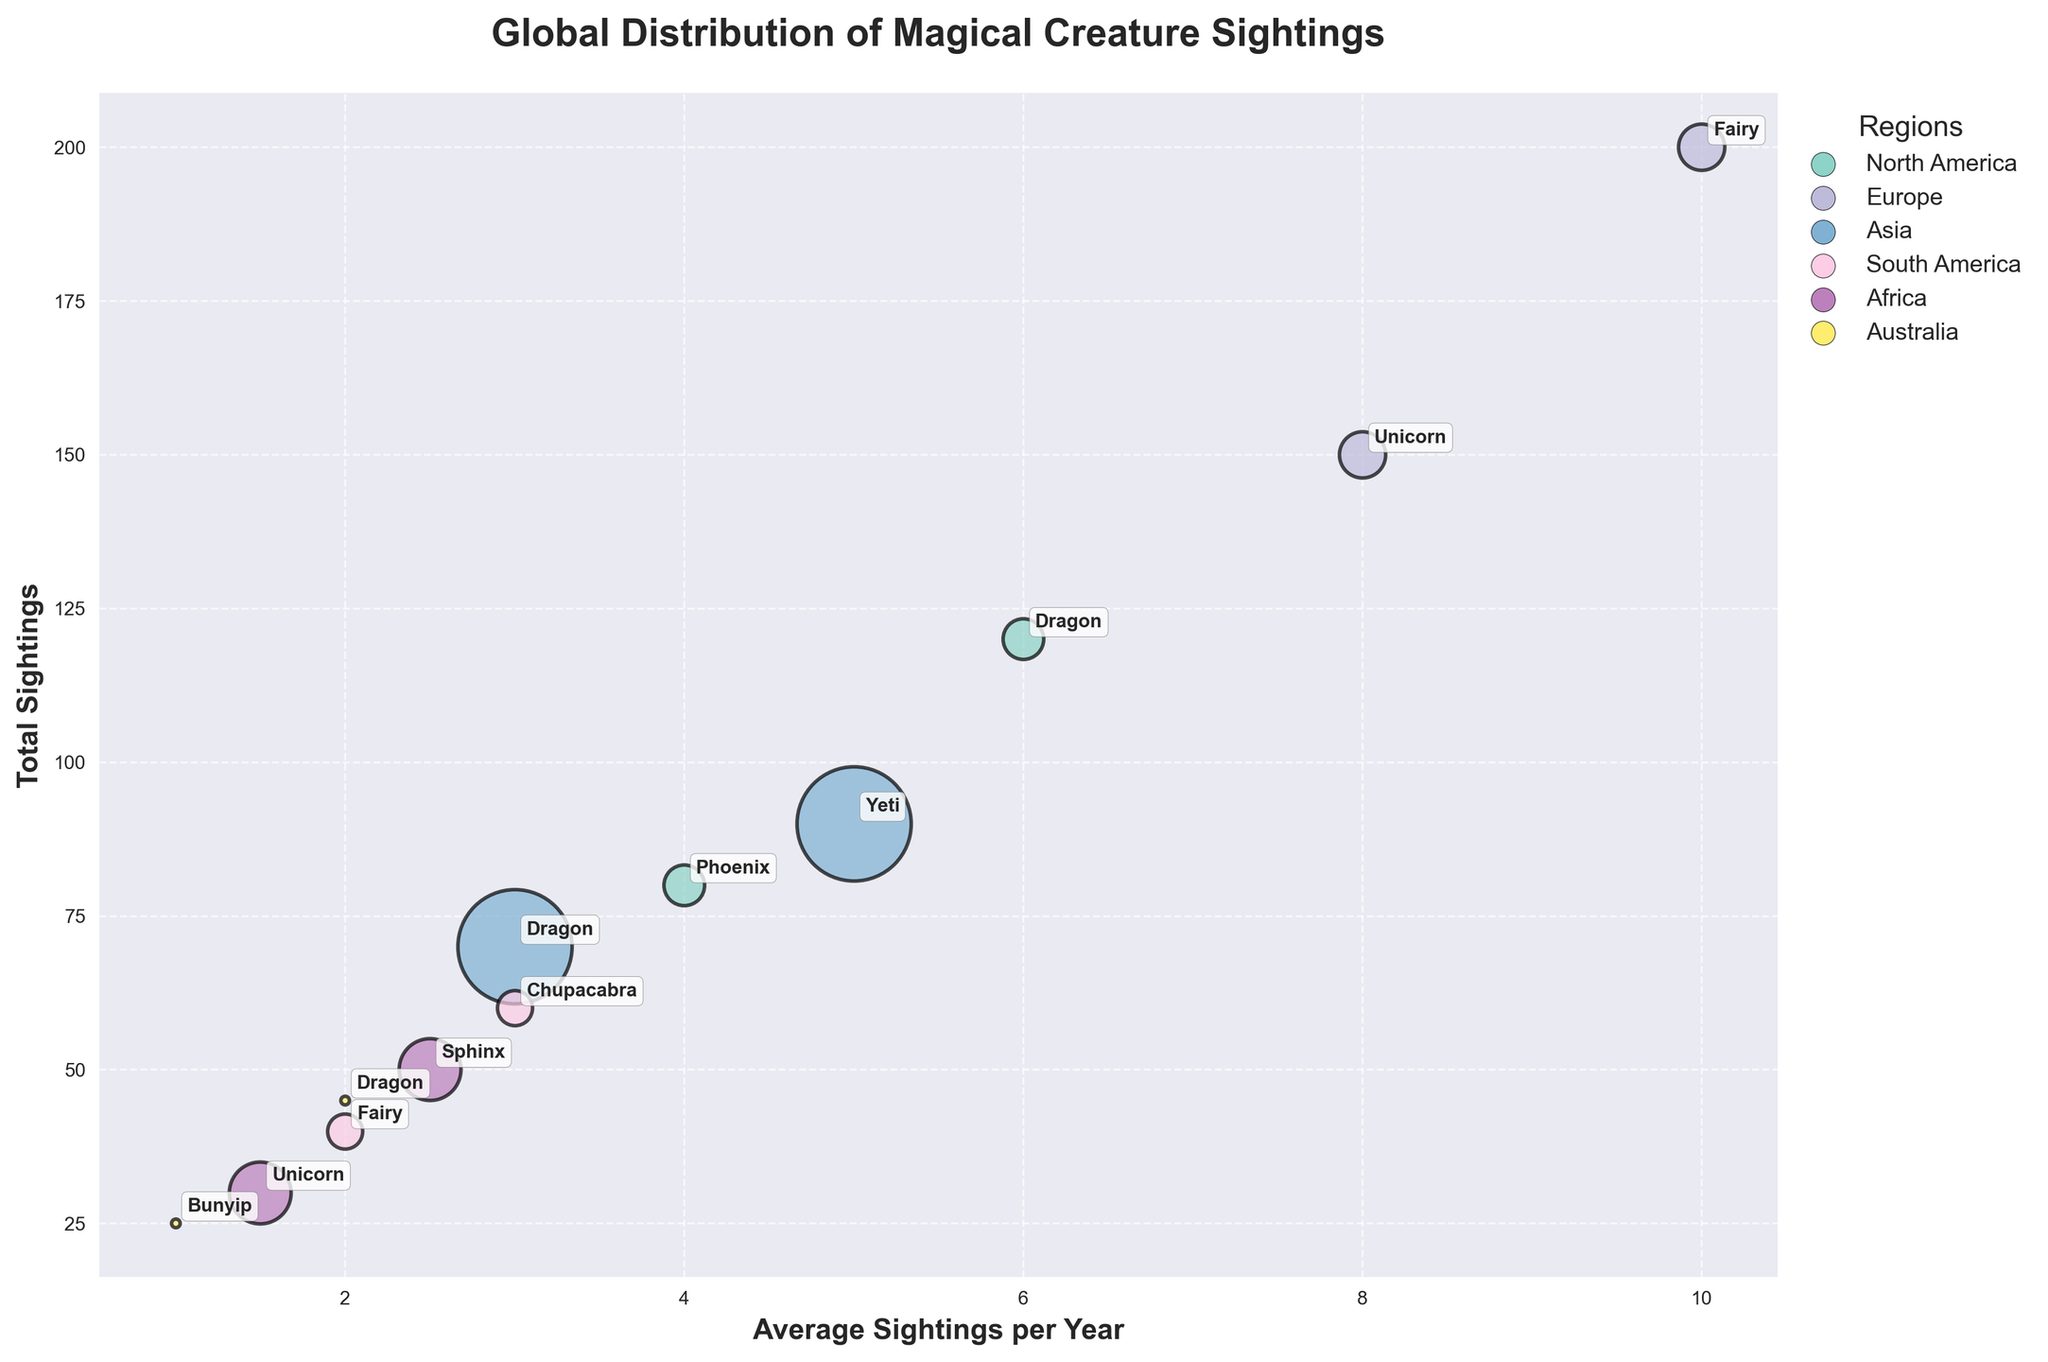What is the title of the chart? The title is placed above the chart, serving as a summary of the chart’s primary focus. It reads “Global Distribution of Magical Creature Sightings”.
Answer: Global Distribution of Magical Creature Sightings How many creature types are represented in Europe? To determine this, identify the unique creature types listed within the Europe region. Europe has two distinct creature types: Unicorn and Fairy.
Answer: 2 Which region has the largest bubble size? The size of the bubble is based on the region population. The largest bubble is from Asia, which corresponds to the largest population.
Answer: Asia What is the total number of sightings reported in North America? Summing up the sightings of Dragons and Phoenix in North America: 120 + 80 = 200
Answer: 200 Which creature type in Asia has the highest average sightings per year? Comparing the average sightings per year of Dragons (3) and Yeti (5), Yeti has the highest average sightings per year.
Answer: Yeti How does the number of sightings in Europe compare for Unicorns and Fairies? Europe has 150 sightings of Unicorns and 200 sightings of Fairies. Fairies have more sightings compared to Unicorns.
Answer: Fairies have more What can you infer about the relationship between population size and bubble size on the chart? Larger populations correspond to larger bubble sizes. For instance, Asia has the largest bubble due to its large population, indicating a direct relationship between population size and bubble size.
Answer: Larger populations result in larger bubbles Which region has the highest total sightings of mythical creatures? Comparing the sighting numbers in each region, Europe has the highest total sightings, summing up Unicorn (150) and Fairy (200) sightings, giving a total of 350.
Answer: Europe What is the average number of sightings per year for all creature types in South America? South America has Chupacabra (3) and Fairy (2). The average of these two values is (3+2)/2 = 2.5.
Answer: 2.5 Which region has Unicorn sightings, and how do their sightings compare between the regions? Unicorn sightings are reported in Europe (150) and Africa (30). Europe's Unicorn sightings (150) are higher than Africa's (30).
Answer: Europe has more Unicorn sightings 